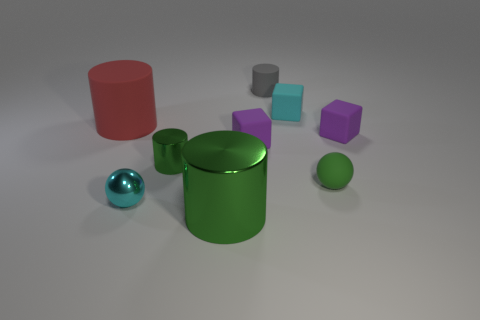What is the material of the object that is both in front of the green ball and left of the big green object?
Offer a very short reply. Metal. Is the color of the large metal cylinder the same as the tiny cylinder that is left of the tiny rubber cylinder?
Offer a terse response. Yes. There is another gray rubber thing that is the same shape as the large rubber object; what size is it?
Provide a short and direct response. Small. The small thing that is both on the left side of the large green shiny object and behind the rubber ball has what shape?
Keep it short and to the point. Cylinder. Do the gray cylinder and the cyan thing that is behind the red thing have the same size?
Offer a terse response. Yes. There is a big metal object that is the same shape as the gray rubber thing; what color is it?
Ensure brevity in your answer.  Green. Does the rubber object that is to the left of the big green cylinder have the same size as the green cylinder that is left of the big green cylinder?
Provide a short and direct response. No. Is the red thing the same shape as the small gray thing?
Your answer should be compact. Yes. What number of things are either small rubber objects right of the green rubber ball or red cylinders?
Your answer should be compact. 2. Are there any other matte things that have the same shape as the tiny cyan matte object?
Offer a terse response. Yes. 